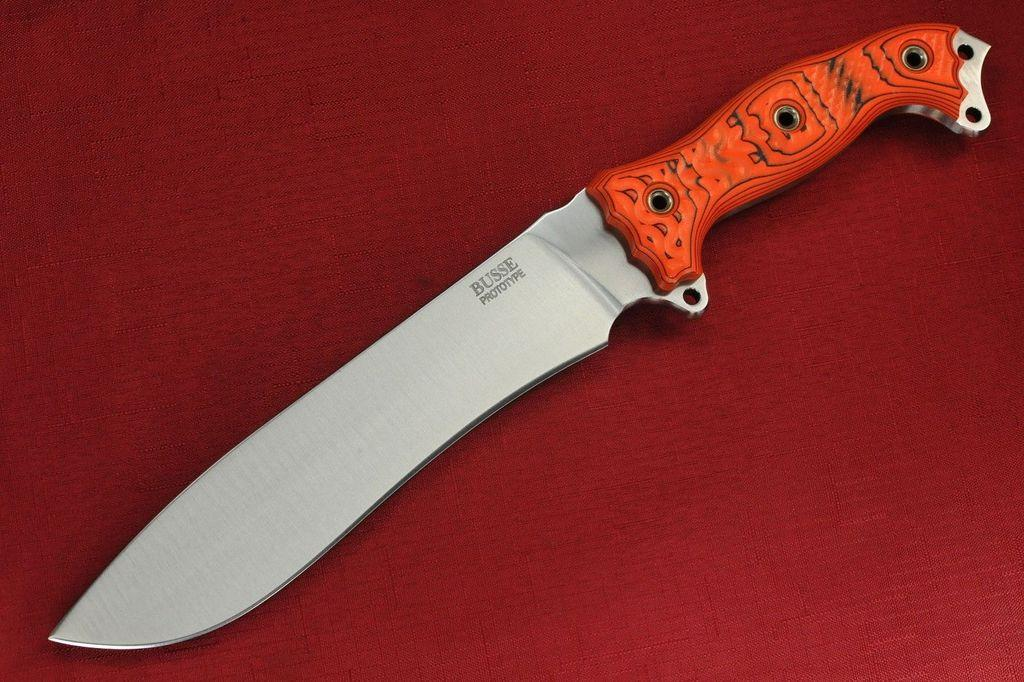What object is present on the table in the image? There is a knife on the table in the image. What color is the cloth on the table? The cloth on the table is red. How does the knife help the lumber in the image? There is no lumber present in the image, and the knife is not interacting with any lumber. 